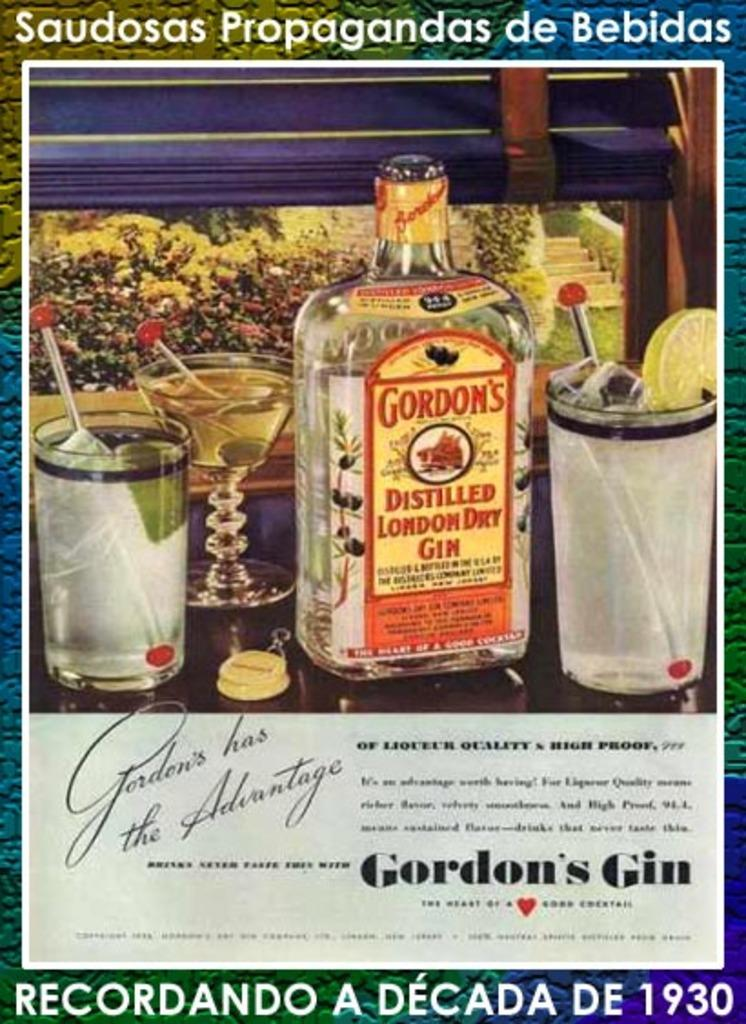<image>
Summarize the visual content of the image. A colorful ad for Gordon's Gin displaying several glasses. 